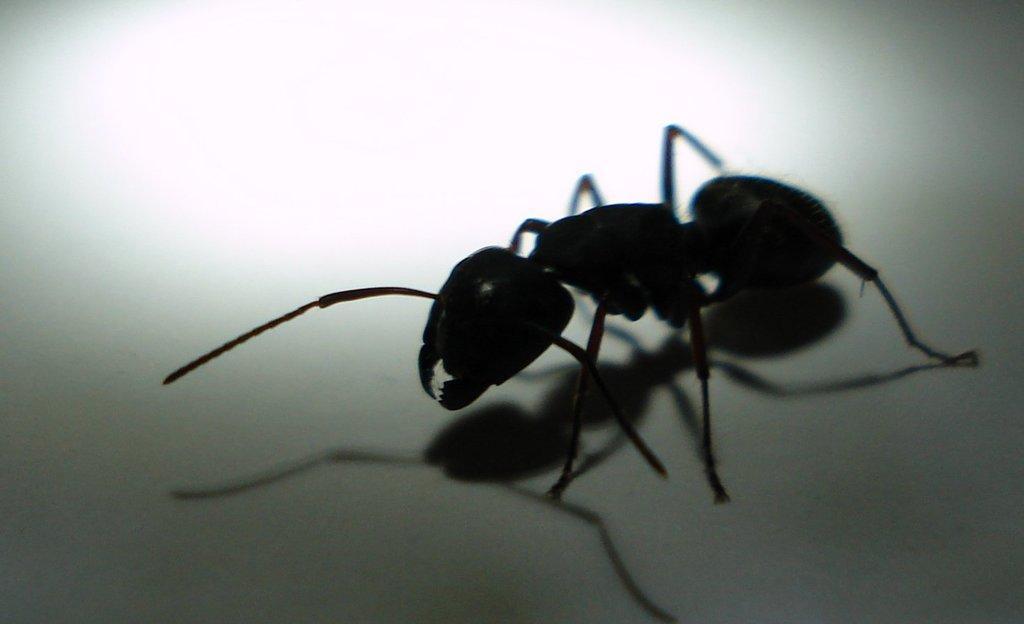Describe this image in one or two sentences. In this image I can see an ant which is black in color on the white colored surface. 